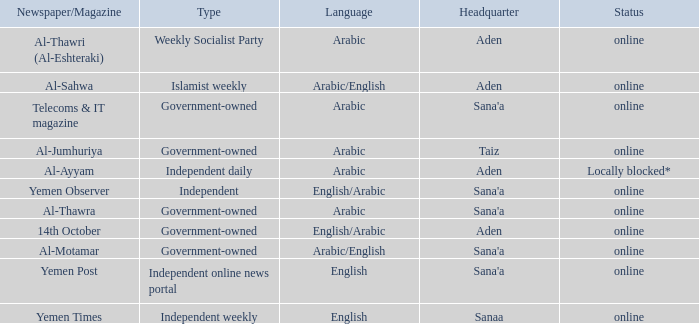What is Headquarter, when Language is English, and when Type is Independent Online News Portal? Sana'a. 